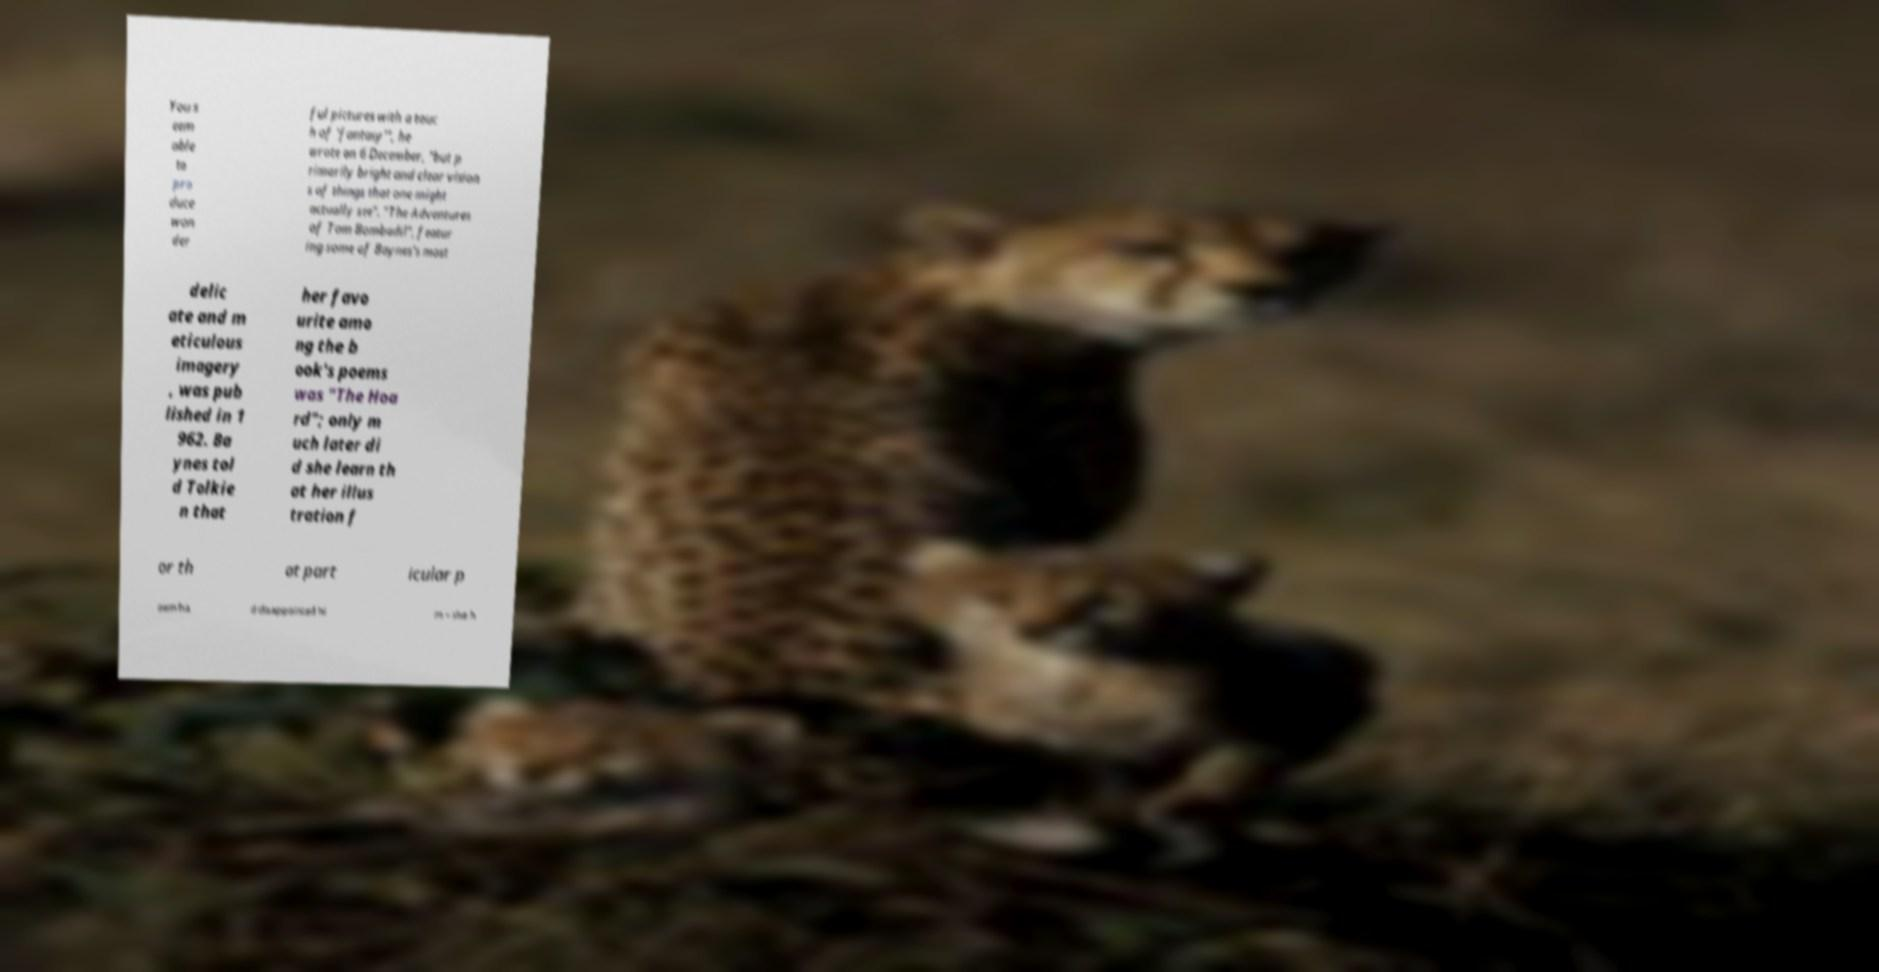Can you accurately transcribe the text from the provided image for me? You s eem able to pro duce won der ful pictures with a touc h of 'fantasy'", he wrote on 6 December, "but p rimarily bright and clear vision s of things that one might actually see". "The Adventures of Tom Bombadil", featur ing some of Baynes's most delic ate and m eticulous imagery , was pub lished in 1 962. Ba ynes tol d Tolkie n that her favo urite amo ng the b ook's poems was "The Hoa rd"; only m uch later di d she learn th at her illus tration f or th at part icular p oem ha d disappointed hi m – she h 